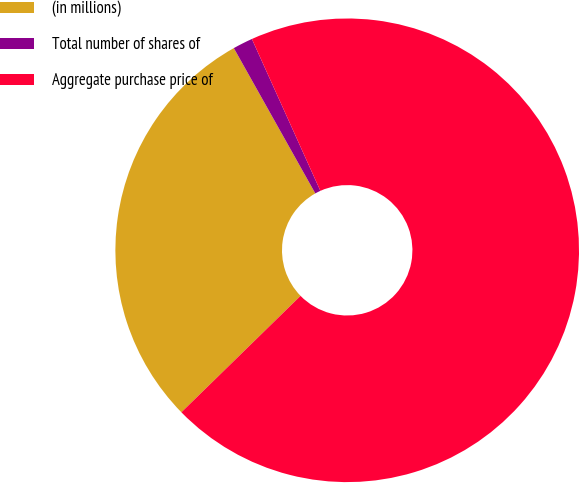<chart> <loc_0><loc_0><loc_500><loc_500><pie_chart><fcel>(in millions)<fcel>Total number of shares of<fcel>Aggregate purchase price of<nl><fcel>29.18%<fcel>1.39%<fcel>69.43%<nl></chart> 